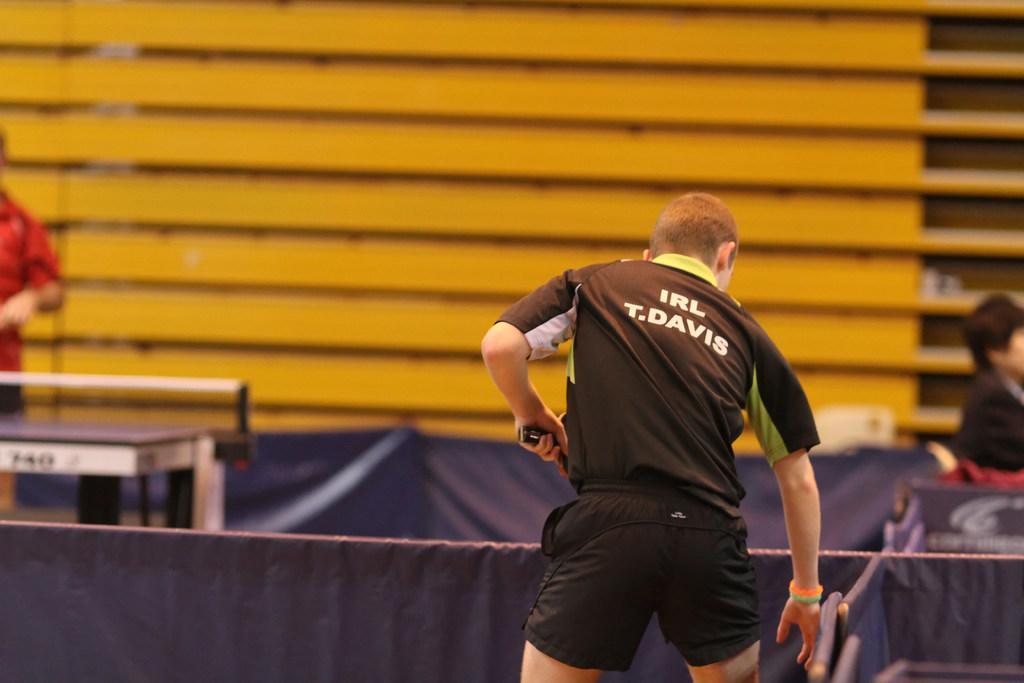Describe this image in one or two sentences. There is a man holding something in the hand. On the right side there is a person sitting. On the left side there is a person standing. In the back there is a wall. 